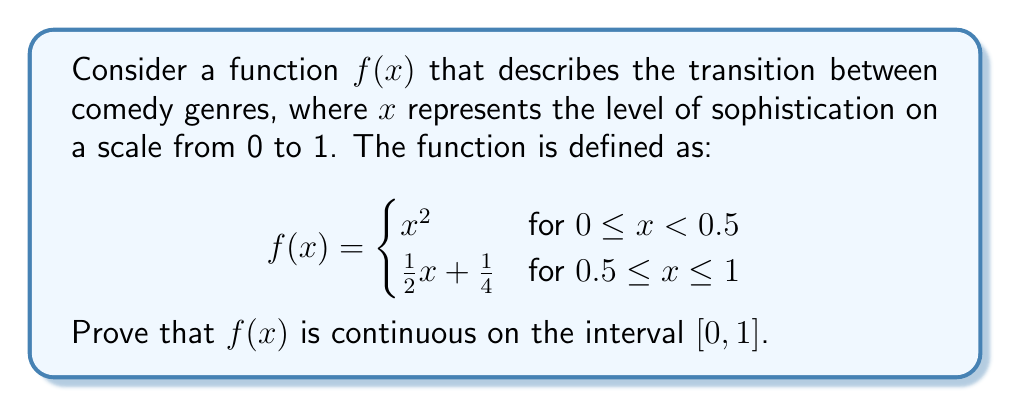Can you solve this math problem? To prove that $f(x)$ is continuous on the interval $[0, 1]$, we need to show:
1. $f(x)$ is continuous on $(0, 0.5)$ and $(0.5, 1)$
2. $f(x)$ is continuous at $x = 0.5$
3. $f(x)$ is continuous at $x = 0$ and $x = 1$

Step 1: Continuity on $(0, 0.5)$ and $(0.5, 1)$
- On $(0, 0.5)$, $f(x) = x^2$, which is a polynomial function and therefore continuous.
- On $(0.5, 1)$, $f(x) = \frac{1}{2}x + \frac{1}{4}$, which is a linear function and therefore continuous.

Step 2: Continuity at $x = 0.5$
To prove continuity at $x = 0.5$, we need to show that:
$$\lim_{x \to 0.5^-} f(x) = \lim_{x \to 0.5^+} f(x) = f(0.5)$$

Left-hand limit:
$$\lim_{x \to 0.5^-} f(x) = \lim_{x \to 0.5^-} x^2 = (0.5)^2 = 0.25$$

Right-hand limit:
$$\lim_{x \to 0.5^+} f(x) = \lim_{x \to 0.5^+} (\frac{1}{2}x + \frac{1}{4}) = \frac{1}{2}(0.5) + \frac{1}{4} = 0.25$$

Value at $x = 0.5$:
$$f(0.5) = \frac{1}{2}(0.5) + \frac{1}{4} = 0.25$$

Since all three values are equal, $f(x)$ is continuous at $x = 0.5$.

Step 3: Continuity at $x = 0$ and $x = 1$
- At $x = 0$: $\lim_{x \to 0^+} f(x) = \lim_{x \to 0^+} x^2 = 0 = f(0)$
- At $x = 1$: $\lim_{x \to 1^-} f(x) = \lim_{x \to 1^-} (\frac{1}{2}x + \frac{1}{4}) = \frac{1}{2}(1) + \frac{1}{4} = \frac{3}{4} = f(1)$

Therefore, $f(x)$ is continuous at both endpoints.

Since $f(x)$ is continuous on all subintervals and at all points in $[0, 1]$, we conclude that $f(x)$ is continuous on the entire interval $[0, 1]$.
Answer: $f(x)$ is continuous on the interval $[0, 1]$. 